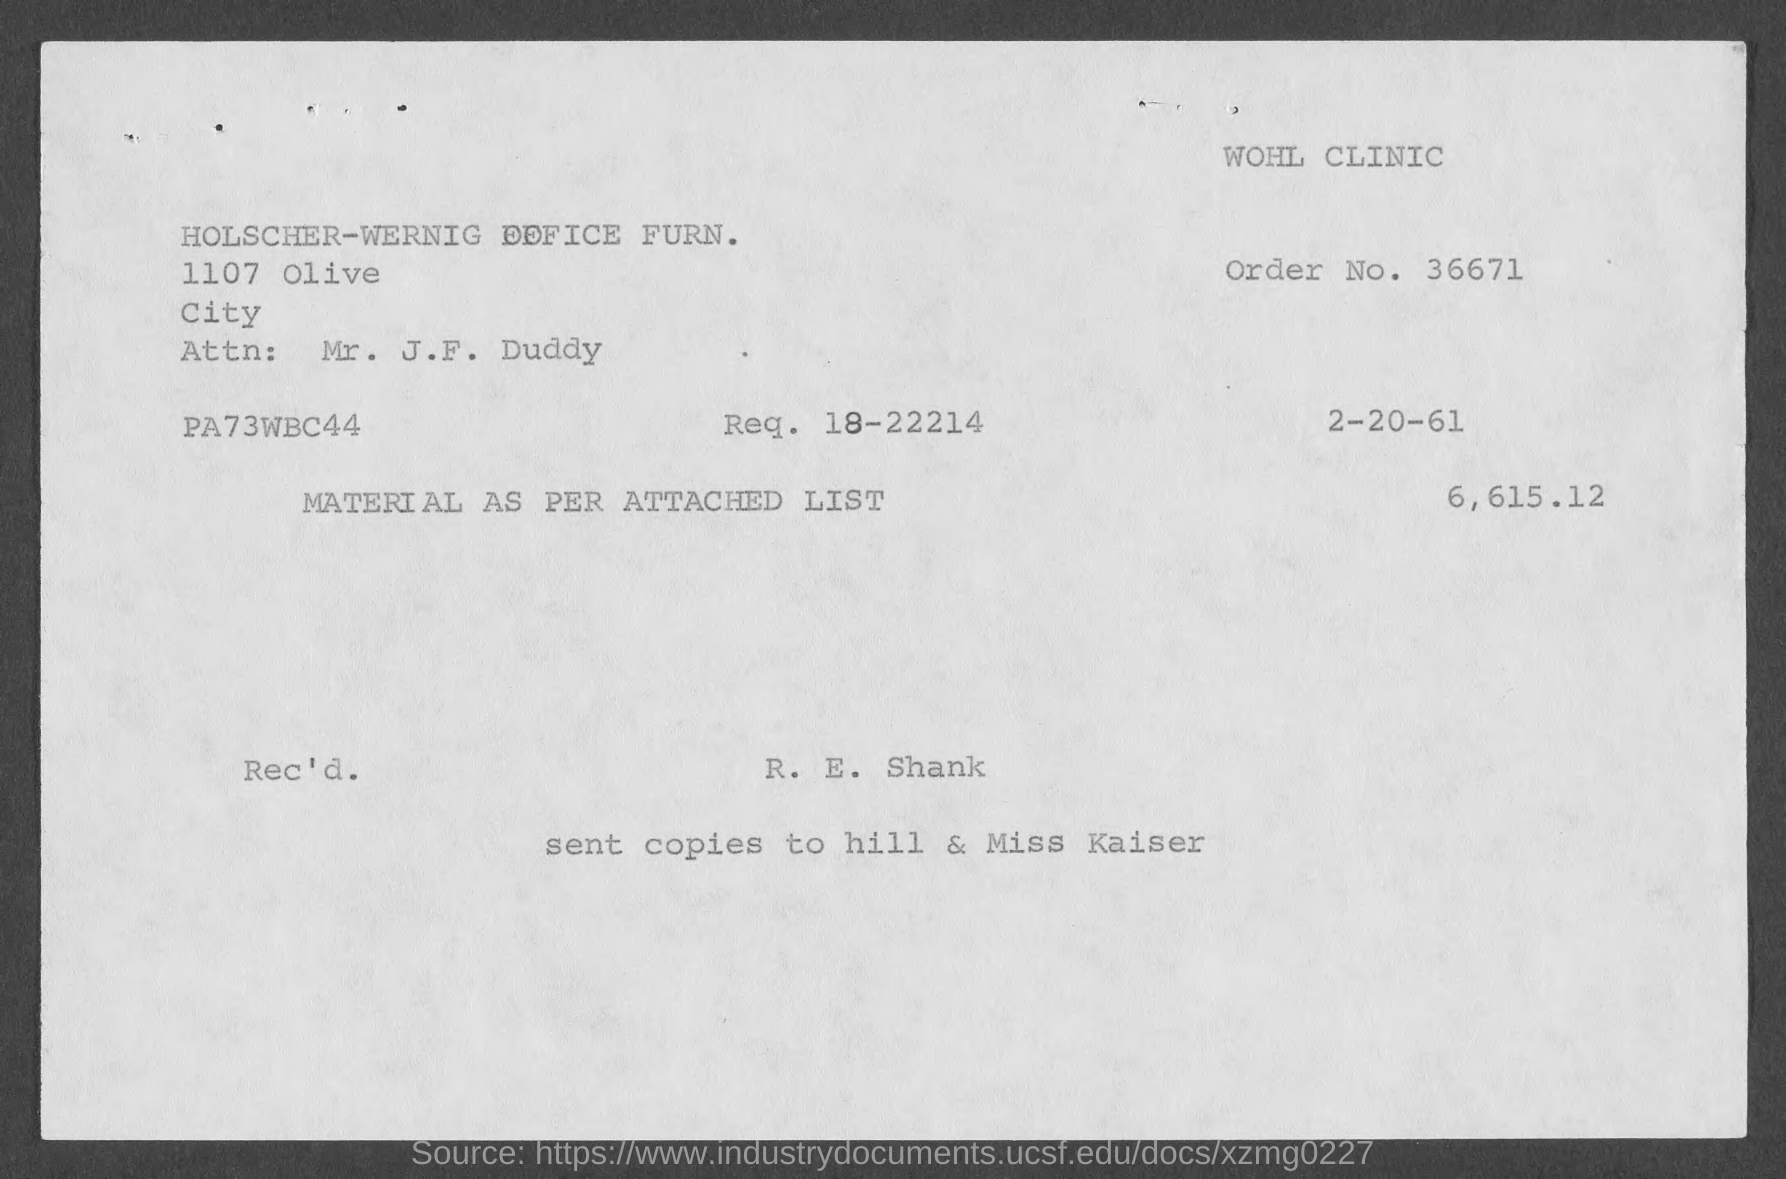Outline some significant characteristics in this image. The person's name is Mr. J. F. Duddy. What is the order number? It is 36671...". Please provide Request Number 18-22214... The name of the clinic is Wohl Clinic. 